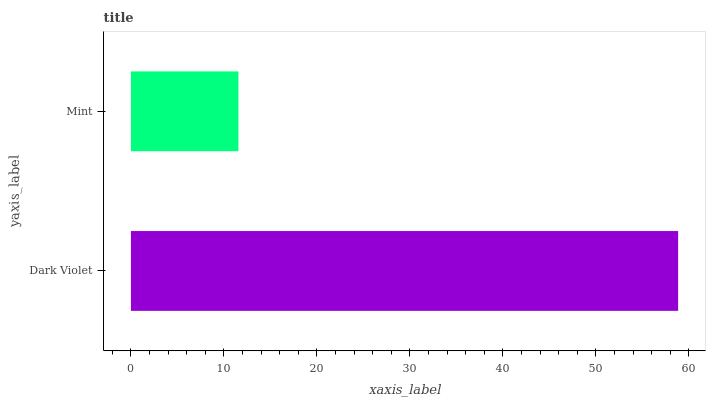Is Mint the minimum?
Answer yes or no. Yes. Is Dark Violet the maximum?
Answer yes or no. Yes. Is Mint the maximum?
Answer yes or no. No. Is Dark Violet greater than Mint?
Answer yes or no. Yes. Is Mint less than Dark Violet?
Answer yes or no. Yes. Is Mint greater than Dark Violet?
Answer yes or no. No. Is Dark Violet less than Mint?
Answer yes or no. No. Is Dark Violet the high median?
Answer yes or no. Yes. Is Mint the low median?
Answer yes or no. Yes. Is Mint the high median?
Answer yes or no. No. Is Dark Violet the low median?
Answer yes or no. No. 